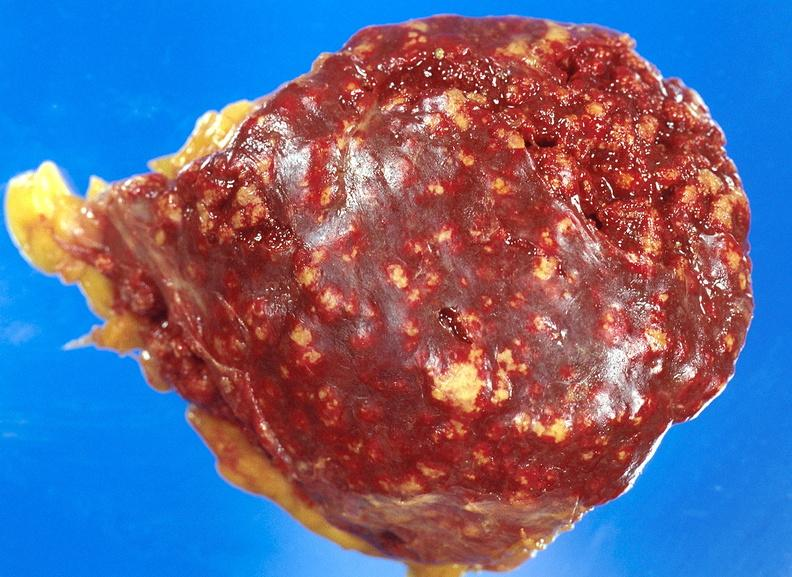does this image show spleen, tuberculosis?
Answer the question using a single word or phrase. Yes 